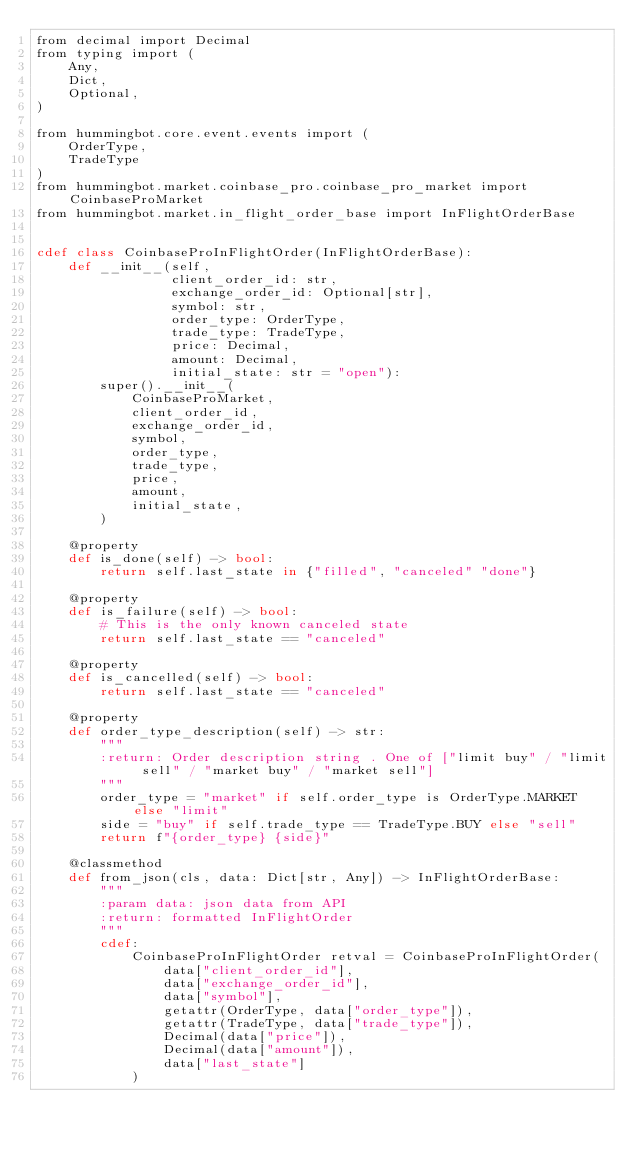Convert code to text. <code><loc_0><loc_0><loc_500><loc_500><_Cython_>from decimal import Decimal
from typing import (
    Any,
    Dict,
    Optional,
)

from hummingbot.core.event.events import (
    OrderType,
    TradeType
)
from hummingbot.market.coinbase_pro.coinbase_pro_market import CoinbaseProMarket
from hummingbot.market.in_flight_order_base import InFlightOrderBase


cdef class CoinbaseProInFlightOrder(InFlightOrderBase):
    def __init__(self,
                 client_order_id: str,
                 exchange_order_id: Optional[str],
                 symbol: str,
                 order_type: OrderType,
                 trade_type: TradeType,
                 price: Decimal,
                 amount: Decimal,
                 initial_state: str = "open"):
        super().__init__(
            CoinbaseProMarket,
            client_order_id,
            exchange_order_id,
            symbol,
            order_type,
            trade_type,
            price,
            amount,
            initial_state,
        )

    @property
    def is_done(self) -> bool:
        return self.last_state in {"filled", "canceled" "done"}

    @property
    def is_failure(self) -> bool:
        # This is the only known canceled state
        return self.last_state == "canceled"

    @property
    def is_cancelled(self) -> bool:
        return self.last_state == "canceled"

    @property
    def order_type_description(self) -> str:
        """
        :return: Order description string . One of ["limit buy" / "limit sell" / "market buy" / "market sell"]
        """
        order_type = "market" if self.order_type is OrderType.MARKET else "limit"
        side = "buy" if self.trade_type == TradeType.BUY else "sell"
        return f"{order_type} {side}"

    @classmethod
    def from_json(cls, data: Dict[str, Any]) -> InFlightOrderBase:
        """
        :param data: json data from API
        :return: formatted InFlightOrder
        """
        cdef:
            CoinbaseProInFlightOrder retval = CoinbaseProInFlightOrder(
                data["client_order_id"],
                data["exchange_order_id"],
                data["symbol"],
                getattr(OrderType, data["order_type"]),
                getattr(TradeType, data["trade_type"]),
                Decimal(data["price"]),
                Decimal(data["amount"]),
                data["last_state"]
            )</code> 